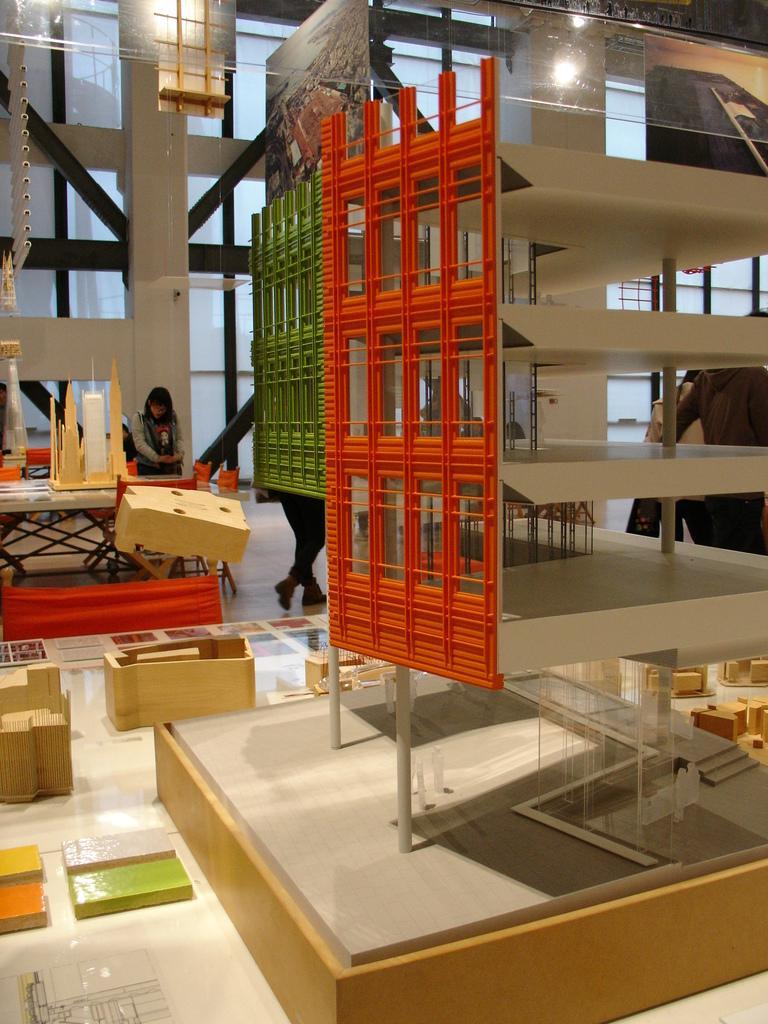Can you describe this image briefly? This image consists of three persons. In which we can see the blocks and buildings made up of those blocks. At the bottom, there is a floor. In the background, we can see the pillars. 